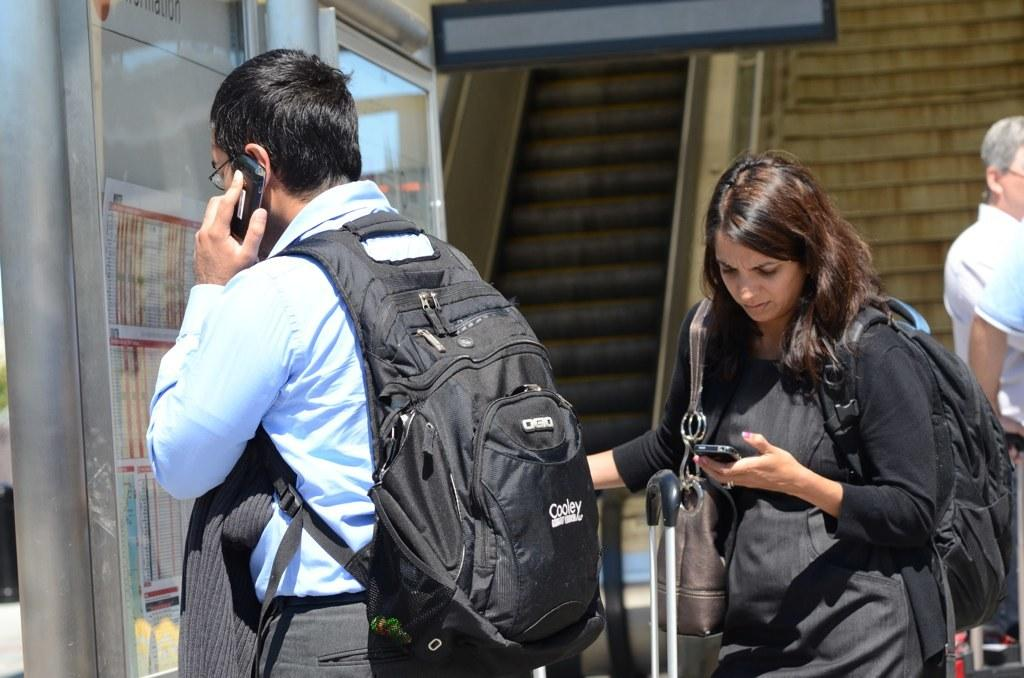<image>
Render a clear and concise summary of the photo. A man talking on a cell phone wears a Cooley brand backpack. 